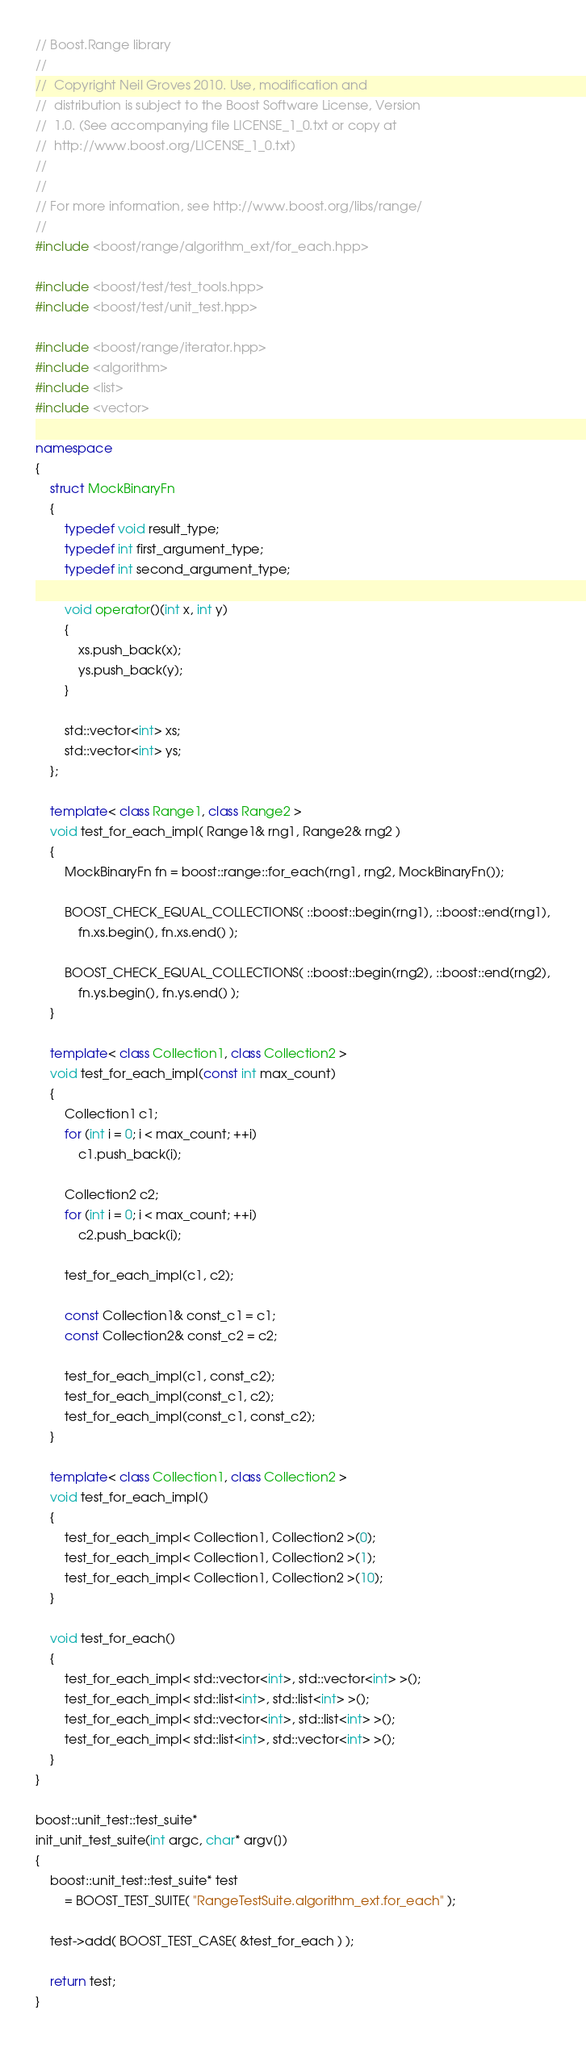<code> <loc_0><loc_0><loc_500><loc_500><_C++_>// Boost.Range library
//
//  Copyright Neil Groves 2010. Use, modification and
//  distribution is subject to the Boost Software License, Version
//  1.0. (See accompanying file LICENSE_1_0.txt or copy at
//  http://www.boost.org/LICENSE_1_0.txt)
//
//
// For more information, see http://www.boost.org/libs/range/
//
#include <boost/range/algorithm_ext/for_each.hpp>

#include <boost/test/test_tools.hpp>
#include <boost/test/unit_test.hpp>

#include <boost/range/iterator.hpp>
#include <algorithm>
#include <list>
#include <vector>

namespace
{
    struct MockBinaryFn
    {
        typedef void result_type;
        typedef int first_argument_type;
        typedef int second_argument_type;

        void operator()(int x, int y)
        {
            xs.push_back(x);
            ys.push_back(y);
        }

        std::vector<int> xs;
        std::vector<int> ys;
    };

    template< class Range1, class Range2 >
    void test_for_each_impl( Range1& rng1, Range2& rng2 )
    {
        MockBinaryFn fn = boost::range::for_each(rng1, rng2, MockBinaryFn());

        BOOST_CHECK_EQUAL_COLLECTIONS( ::boost::begin(rng1), ::boost::end(rng1),
            fn.xs.begin(), fn.xs.end() );

        BOOST_CHECK_EQUAL_COLLECTIONS( ::boost::begin(rng2), ::boost::end(rng2),
            fn.ys.begin(), fn.ys.end() );
    }

    template< class Collection1, class Collection2 >
    void test_for_each_impl(const int max_count)
    {
        Collection1 c1;
        for (int i = 0; i < max_count; ++i)
            c1.push_back(i);

        Collection2 c2;
        for (int i = 0; i < max_count; ++i)
            c2.push_back(i);

        test_for_each_impl(c1, c2);

        const Collection1& const_c1 = c1;
        const Collection2& const_c2 = c2;

        test_for_each_impl(c1, const_c2);
        test_for_each_impl(const_c1, c2);
        test_for_each_impl(const_c1, const_c2);
    }

    template< class Collection1, class Collection2 >
    void test_for_each_impl()
    {
        test_for_each_impl< Collection1, Collection2 >(0);
        test_for_each_impl< Collection1, Collection2 >(1);
        test_for_each_impl< Collection1, Collection2 >(10);
    }

    void test_for_each()
    {
        test_for_each_impl< std::vector<int>, std::vector<int> >();
        test_for_each_impl< std::list<int>, std::list<int> >();
        test_for_each_impl< std::vector<int>, std::list<int> >();
        test_for_each_impl< std::list<int>, std::vector<int> >();
    }
}

boost::unit_test::test_suite*
init_unit_test_suite(int argc, char* argv[])
{
    boost::unit_test::test_suite* test
        = BOOST_TEST_SUITE( "RangeTestSuite.algorithm_ext.for_each" );

    test->add( BOOST_TEST_CASE( &test_for_each ) );

    return test;
}
</code> 